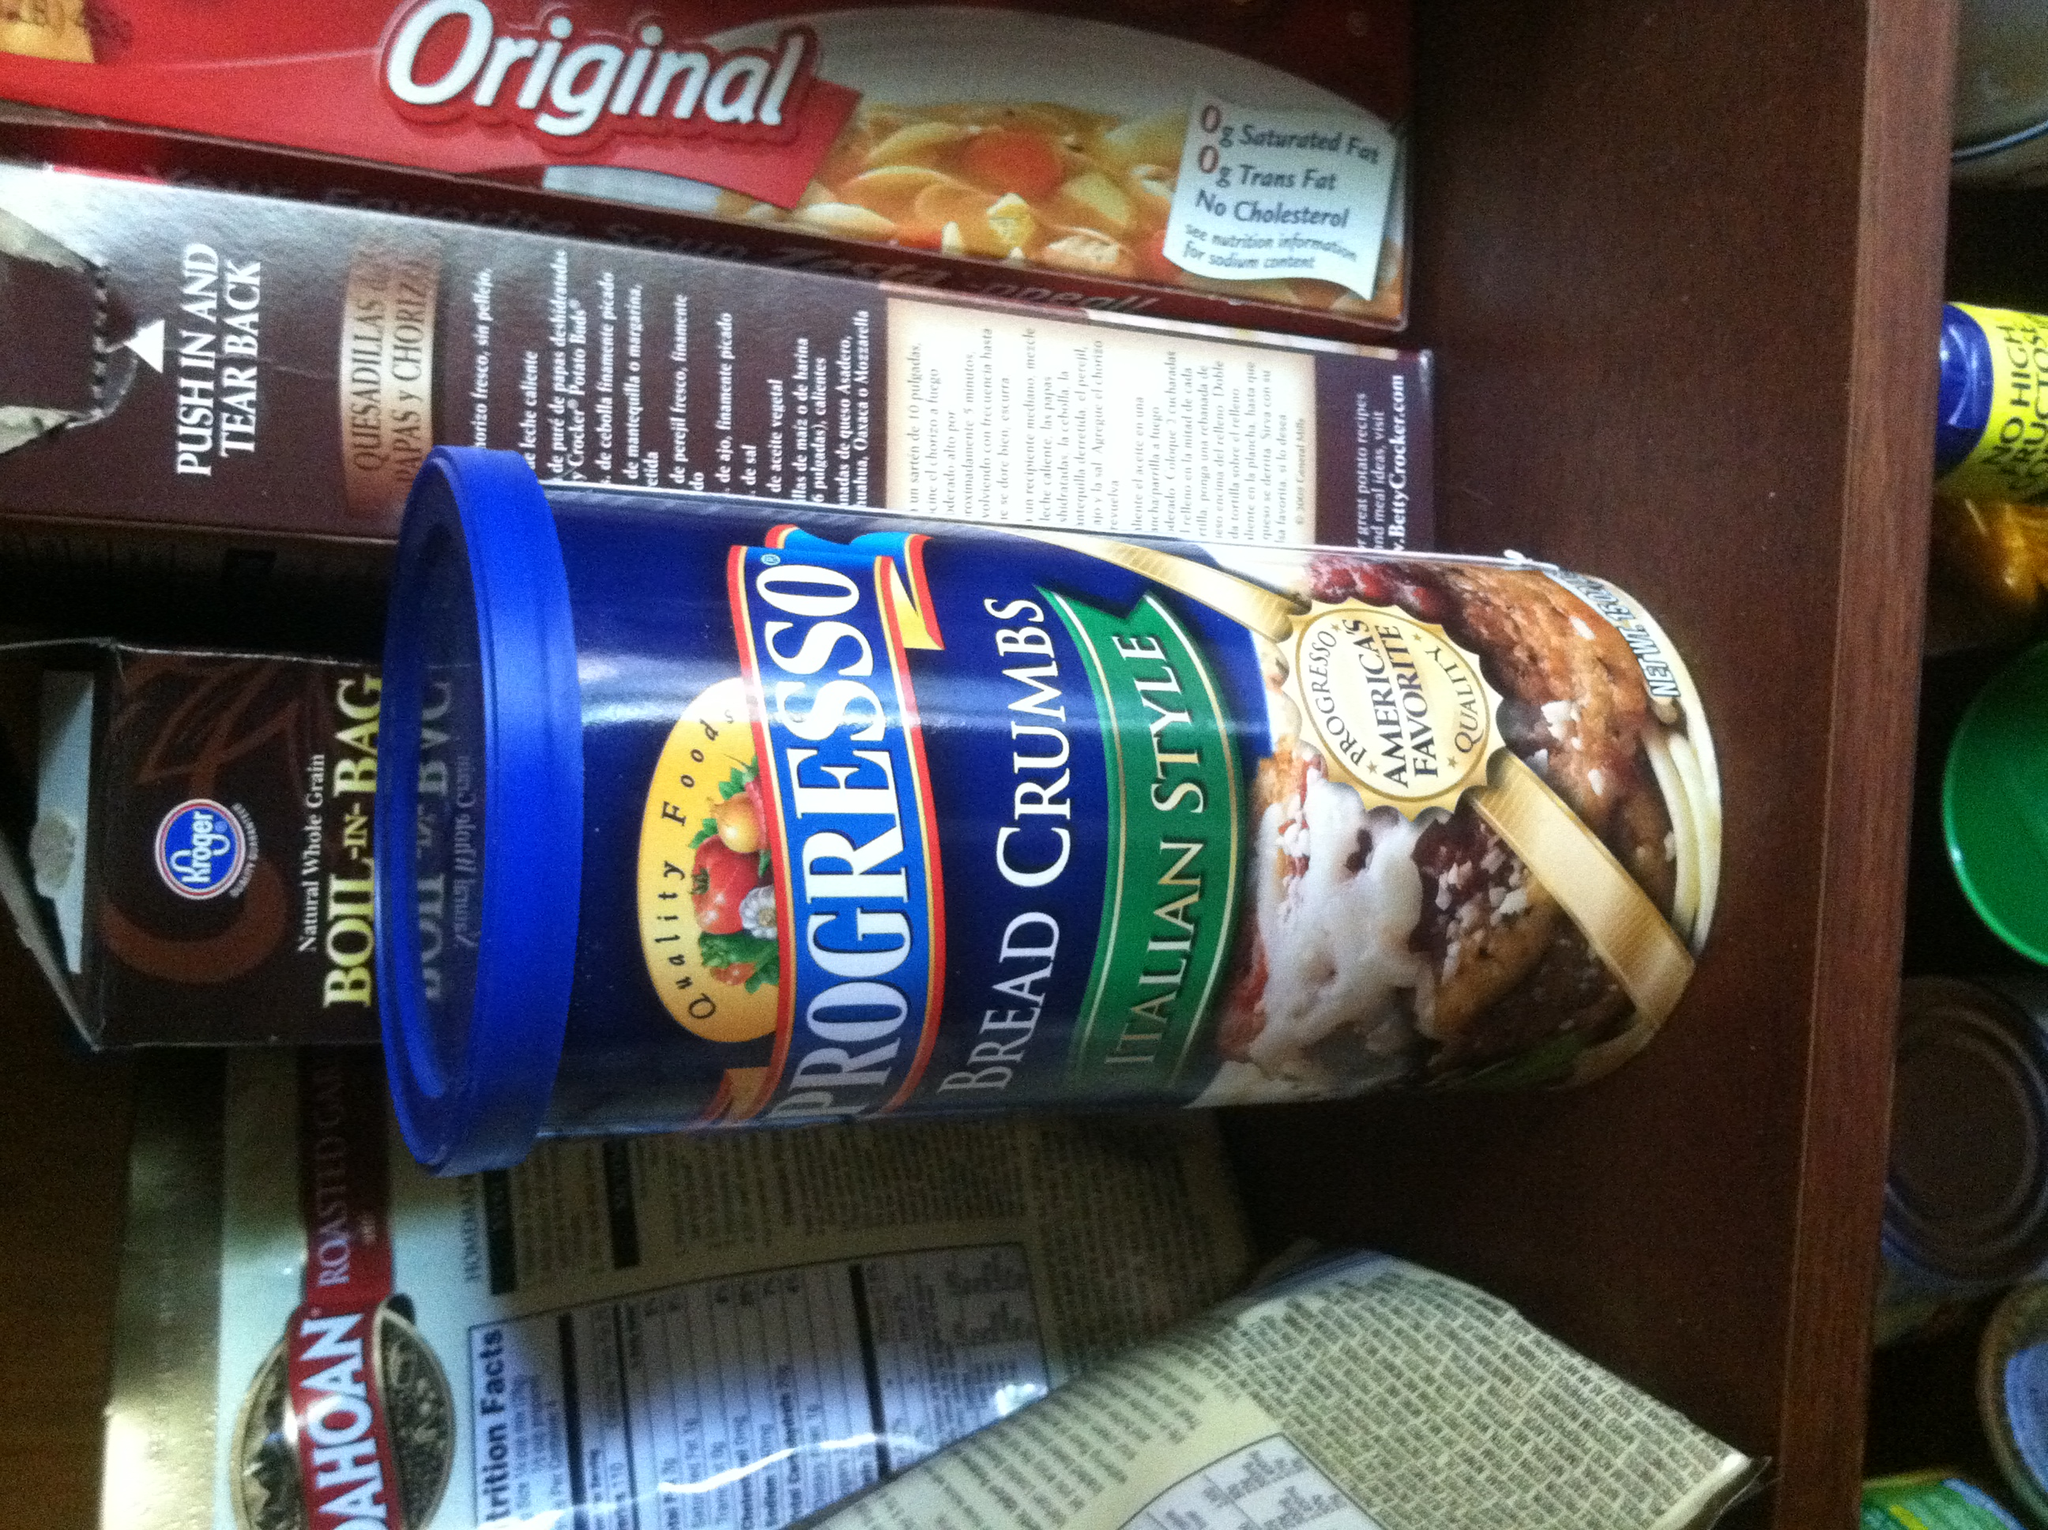What other products do you see in the image? In addition to the Progresso Bread Crumbs, the image shows boxes of Original macaroni and cheese, a box of Kroger Boil-in-Bag Whole Grain Brown Rice, and a Mahatma bag that appears to contain some sort of roasted grains. These items together suggest that the pantry contains a variety of ingredients for different types of meals, from pasta to rice dishes. How can I use all these ingredients together in one meal? Creating a meal that incorporates these diverse ingredients can be a delightful culinary challenge. Here’s one idea: you could make a cheesy rice bake. Start by cooking the macaroni and cheese as per the instructions. Then, cook the brown rice and mix it with the prepared macaroni and cheese in a large baking dish. Add in any extra vegetables or proteins you like; for example, diced chicken, broccoli, or peas would be delicious. Top the mixture with a generous layer of the Progresso Bread Crumbs mixed with some grated cheese and bake in the oven until the top is golden and crunchy. This dish will combine the creamy cheesiness of mac and cheese with the hearty texture of rice and the satisfying crunch of seasoned bread crumbs. Can you create a very imaginative and whimsical recipe for a fantastical meal using these items? Once upon a time in the enchanted pantry, where every ingredient had a story, a brave chef decided to create a legendary dish: The Dragon’s Delight Casserole. Begin by cooking the mystical Whole Grain Brown Rice, rumored to be from the fields of faraway lands. Meanwhile, prepare the enchanted Original macaroni and cheese, which gleams like golden sunshine. Combine these two in a magical cauldron (or a large mixing bowl) and add in mythical ingredients: roasted phoenix peppers (red bell peppers) and elven garden peas for a touch of forest flavor. Blend them thoroughly, chanting an ancient culinary spell (or just mixing well). Next, for crunch and protection from fire-breathing dragons, top the mixture with Progresso's Italian Style Bread Crumbs, believed to be seasoned by the finest herbal witches in the land. Bake this mystical medley until it’s golden and bubbling, and as you pull it from the oven, the aroma will transport you to the fabled banquets of medieval kings. Serve it to your table of knights, wizards, and nobles, and watch as they revel in the extraordinary flavors of the Dragon’s Delight Casserole, a truly fantastical feast! 